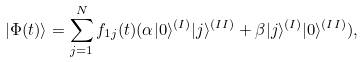<formula> <loc_0><loc_0><loc_500><loc_500>| \Phi ( t ) \rangle = \sum _ { j = 1 } ^ { N } f _ { 1 j } ( t ) ( \alpha | { 0 } \rangle ^ { ( I ) } | { j } \rangle ^ { ( I I ) } + \beta | { j } \rangle ^ { ( I ) } | { 0 } \rangle ^ { ( I I ) } ) ,</formula> 